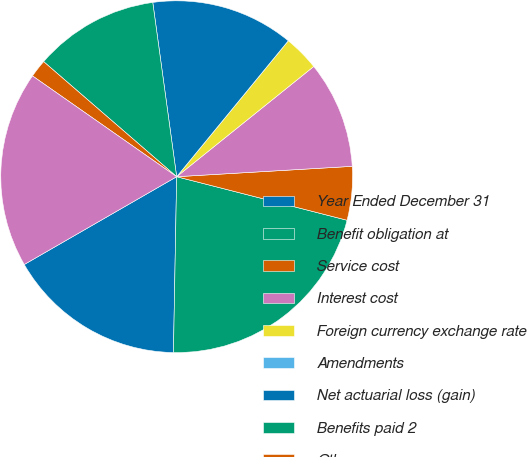Convert chart. <chart><loc_0><loc_0><loc_500><loc_500><pie_chart><fcel>Year Ended December 31<fcel>Benefit obligation at<fcel>Service cost<fcel>Interest cost<fcel>Foreign currency exchange rate<fcel>Amendments<fcel>Net actuarial loss (gain)<fcel>Benefits paid 2<fcel>Other<fcel>Benefit obligation at end of<nl><fcel>16.39%<fcel>21.31%<fcel>4.92%<fcel>9.84%<fcel>3.28%<fcel>0.0%<fcel>13.11%<fcel>11.48%<fcel>1.64%<fcel>18.03%<nl></chart> 